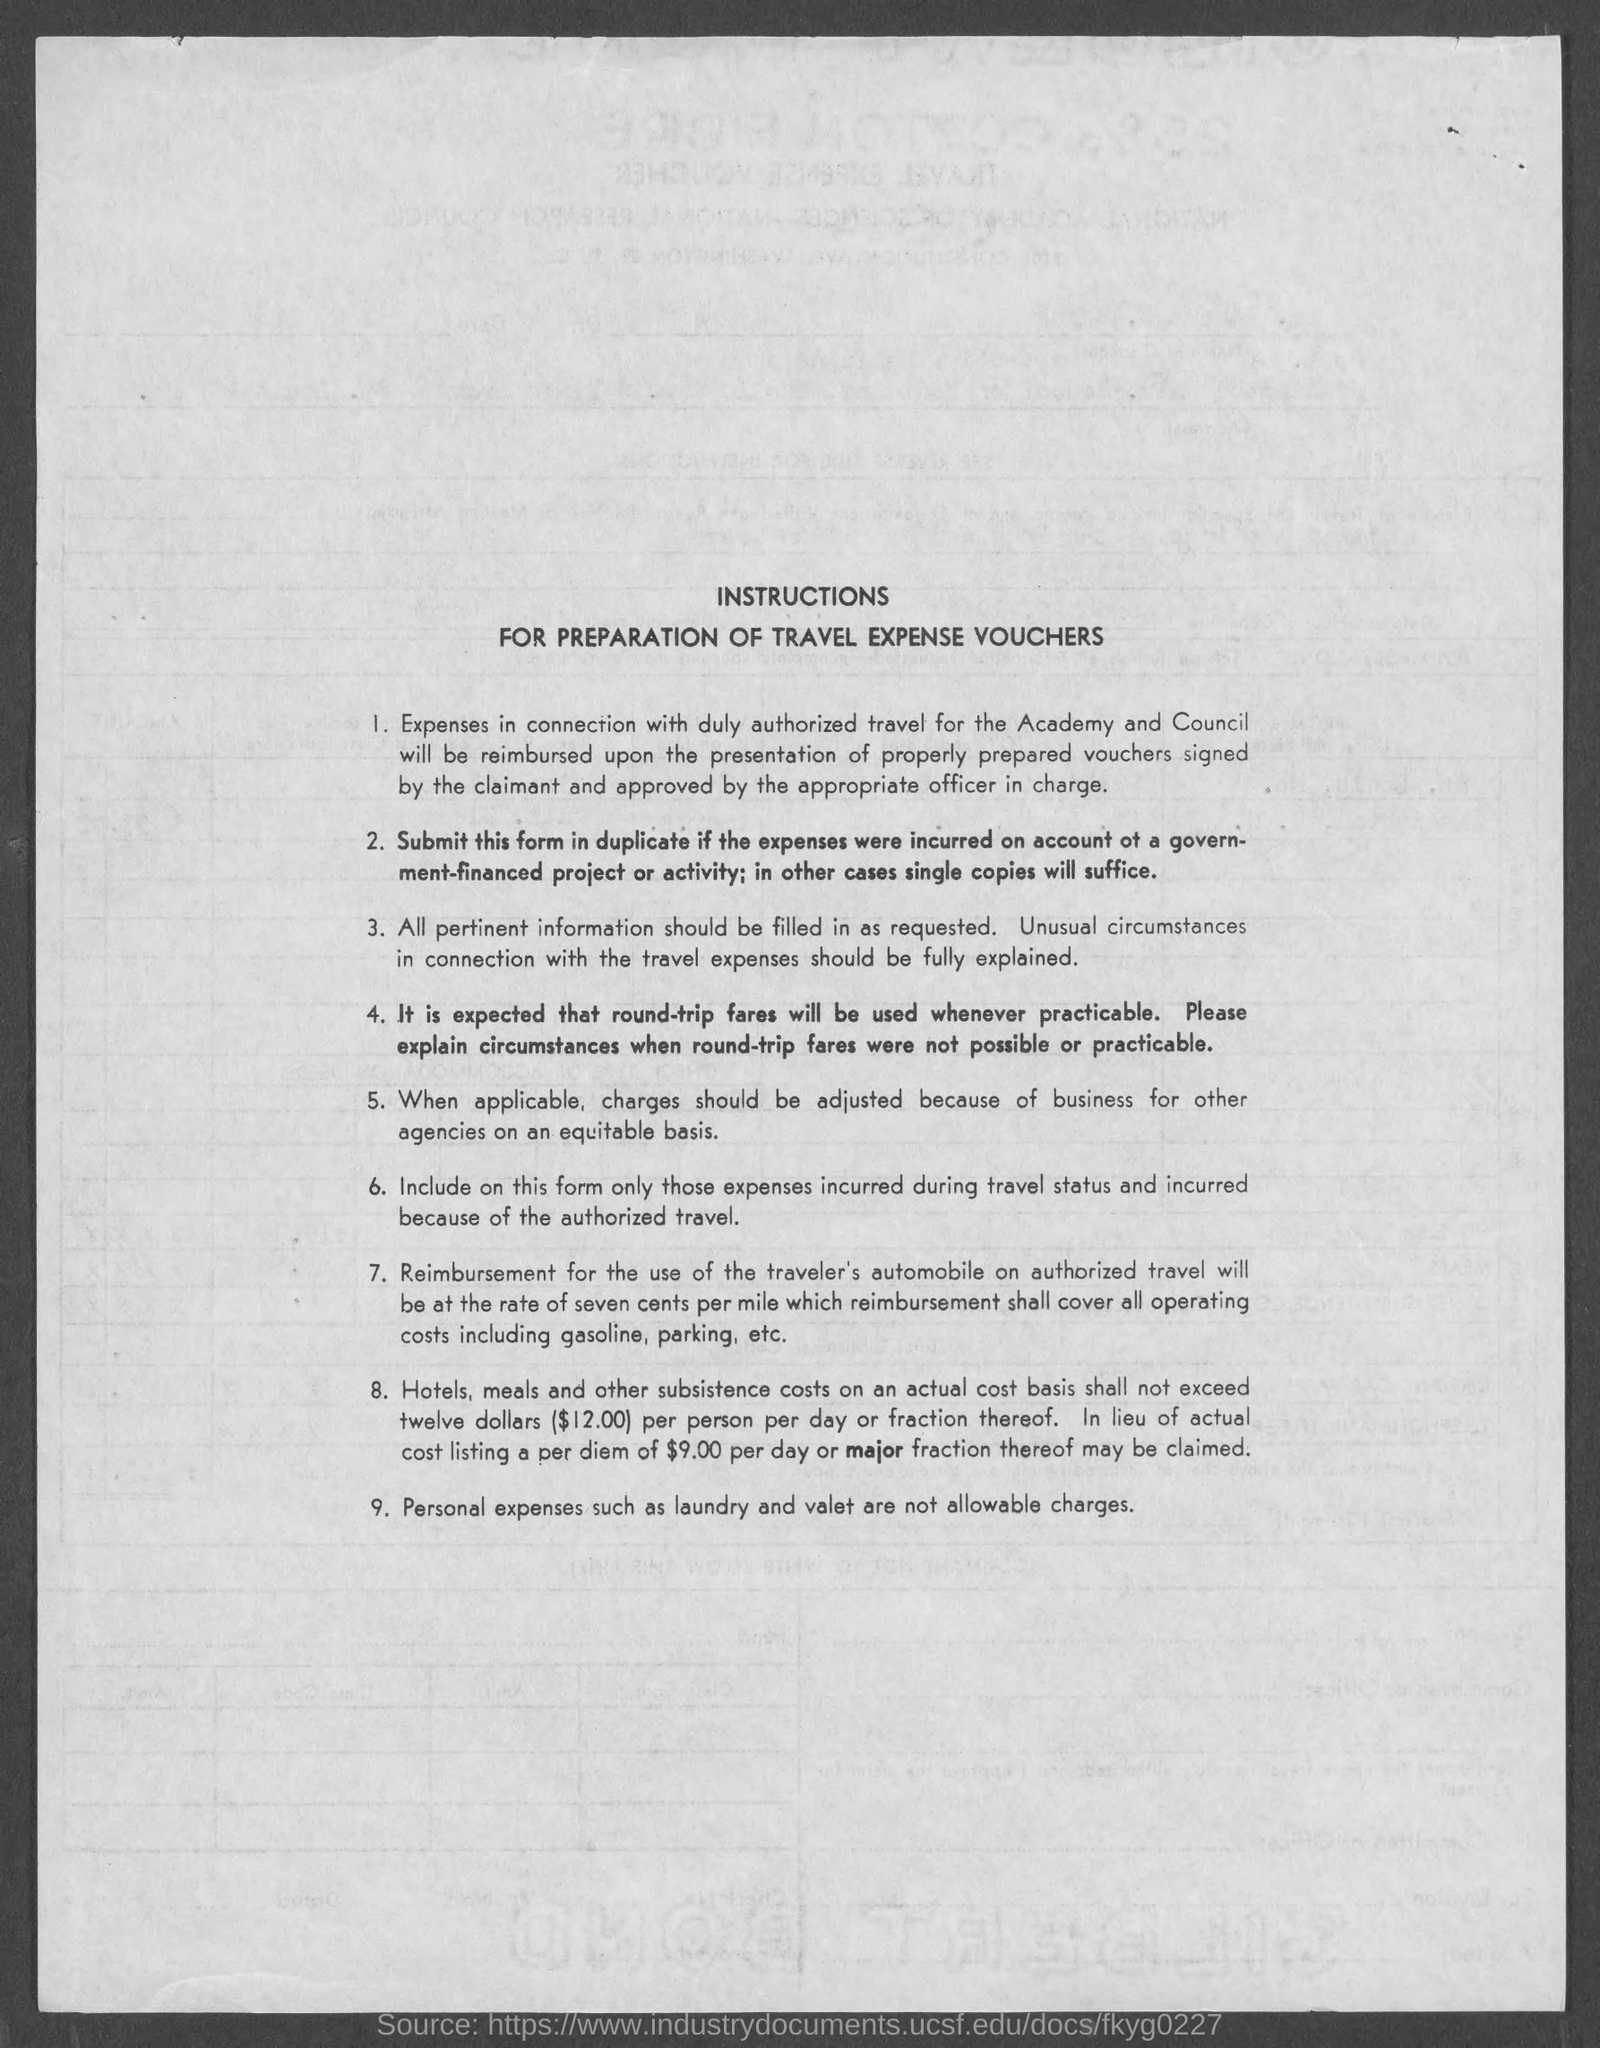What is the title of the document?
Provide a short and direct response. Instructions for preparation of travel expense vouchers. 